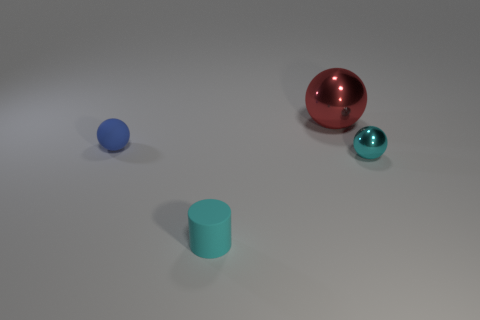Add 1 matte objects. How many objects exist? 5 Subtract all cylinders. How many objects are left? 3 Add 1 cylinders. How many cylinders exist? 2 Subtract 0 cyan blocks. How many objects are left? 4 Subtract all blue spheres. Subtract all tiny blue things. How many objects are left? 2 Add 4 big metallic things. How many big metallic things are left? 5 